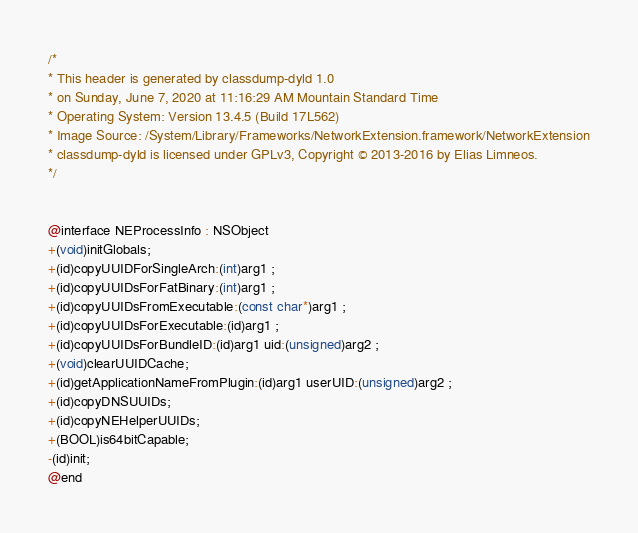Convert code to text. <code><loc_0><loc_0><loc_500><loc_500><_C_>/*
* This header is generated by classdump-dyld 1.0
* on Sunday, June 7, 2020 at 11:16:29 AM Mountain Standard Time
* Operating System: Version 13.4.5 (Build 17L562)
* Image Source: /System/Library/Frameworks/NetworkExtension.framework/NetworkExtension
* classdump-dyld is licensed under GPLv3, Copyright © 2013-2016 by Elias Limneos.
*/


@interface NEProcessInfo : NSObject
+(void)initGlobals;
+(id)copyUUIDForSingleArch:(int)arg1 ;
+(id)copyUUIDsForFatBinary:(int)arg1 ;
+(id)copyUUIDsFromExecutable:(const char*)arg1 ;
+(id)copyUUIDsForExecutable:(id)arg1 ;
+(id)copyUUIDsForBundleID:(id)arg1 uid:(unsigned)arg2 ;
+(void)clearUUIDCache;
+(id)getApplicationNameFromPlugin:(id)arg1 userUID:(unsigned)arg2 ;
+(id)copyDNSUUIDs;
+(id)copyNEHelperUUIDs;
+(BOOL)is64bitCapable;
-(id)init;
@end

</code> 